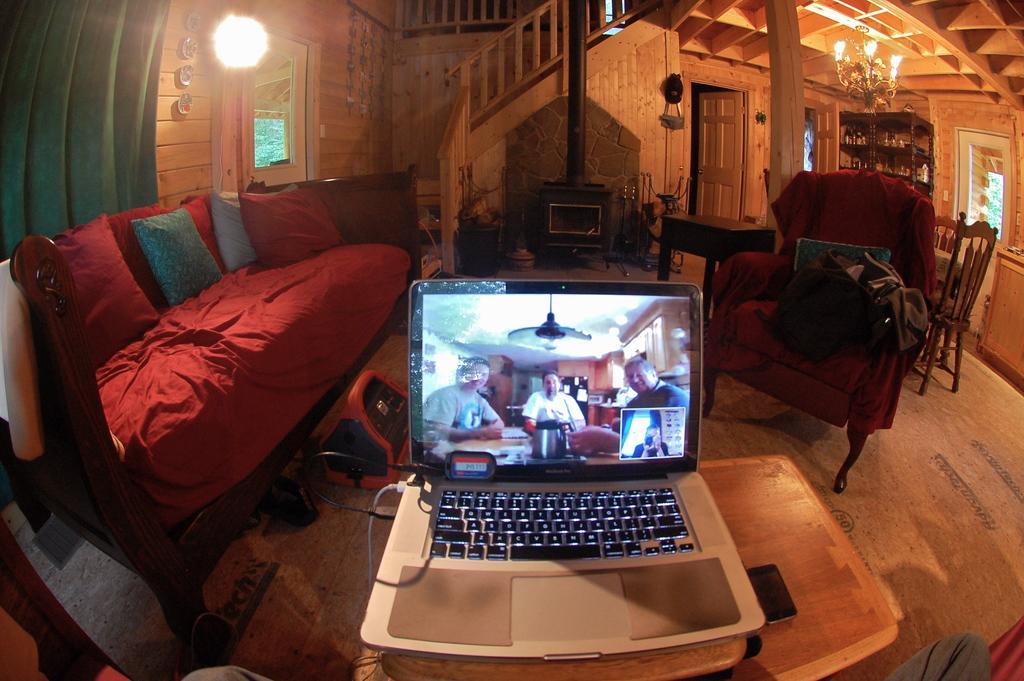Can you describe this image briefly? Here there is sofa,laptop,plant,building light and on the table there is phone. 